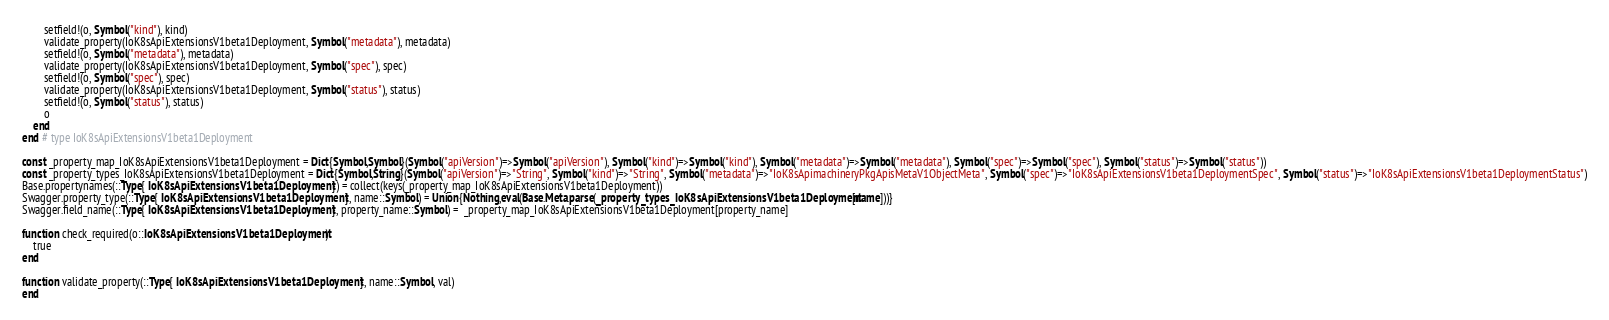<code> <loc_0><loc_0><loc_500><loc_500><_Julia_>        setfield!(o, Symbol("kind"), kind)
        validate_property(IoK8sApiExtensionsV1beta1Deployment, Symbol("metadata"), metadata)
        setfield!(o, Symbol("metadata"), metadata)
        validate_property(IoK8sApiExtensionsV1beta1Deployment, Symbol("spec"), spec)
        setfield!(o, Symbol("spec"), spec)
        validate_property(IoK8sApiExtensionsV1beta1Deployment, Symbol("status"), status)
        setfield!(o, Symbol("status"), status)
        o
    end
end # type IoK8sApiExtensionsV1beta1Deployment

const _property_map_IoK8sApiExtensionsV1beta1Deployment = Dict{Symbol,Symbol}(Symbol("apiVersion")=>Symbol("apiVersion"), Symbol("kind")=>Symbol("kind"), Symbol("metadata")=>Symbol("metadata"), Symbol("spec")=>Symbol("spec"), Symbol("status")=>Symbol("status"))
const _property_types_IoK8sApiExtensionsV1beta1Deployment = Dict{Symbol,String}(Symbol("apiVersion")=>"String", Symbol("kind")=>"String", Symbol("metadata")=>"IoK8sApimachineryPkgApisMetaV1ObjectMeta", Symbol("spec")=>"IoK8sApiExtensionsV1beta1DeploymentSpec", Symbol("status")=>"IoK8sApiExtensionsV1beta1DeploymentStatus")
Base.propertynames(::Type{ IoK8sApiExtensionsV1beta1Deployment }) = collect(keys(_property_map_IoK8sApiExtensionsV1beta1Deployment))
Swagger.property_type(::Type{ IoK8sApiExtensionsV1beta1Deployment }, name::Symbol) = Union{Nothing,eval(Base.Meta.parse(_property_types_IoK8sApiExtensionsV1beta1Deployment[name]))}
Swagger.field_name(::Type{ IoK8sApiExtensionsV1beta1Deployment }, property_name::Symbol) =  _property_map_IoK8sApiExtensionsV1beta1Deployment[property_name]

function check_required(o::IoK8sApiExtensionsV1beta1Deployment)
    true
end

function validate_property(::Type{ IoK8sApiExtensionsV1beta1Deployment }, name::Symbol, val)
end
</code> 